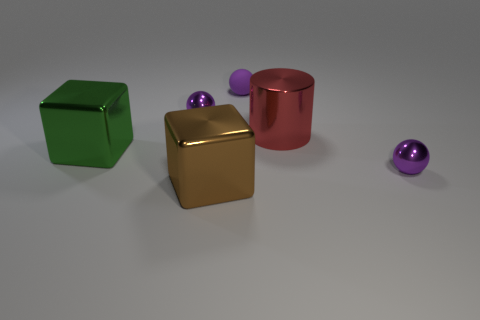Subtract all purple spheres. How many were subtracted if there are1purple spheres left? 2 Add 4 tiny purple rubber objects. How many objects exist? 10 Subtract all tiny purple metal spheres. How many spheres are left? 1 Add 4 green metallic blocks. How many green metallic blocks exist? 5 Subtract 0 gray blocks. How many objects are left? 6 Subtract all cylinders. How many objects are left? 5 Subtract all blue balls. Subtract all yellow cylinders. How many balls are left? 3 Subtract all small purple metallic spheres. Subtract all brown shiny blocks. How many objects are left? 3 Add 4 red metal things. How many red metal things are left? 5 